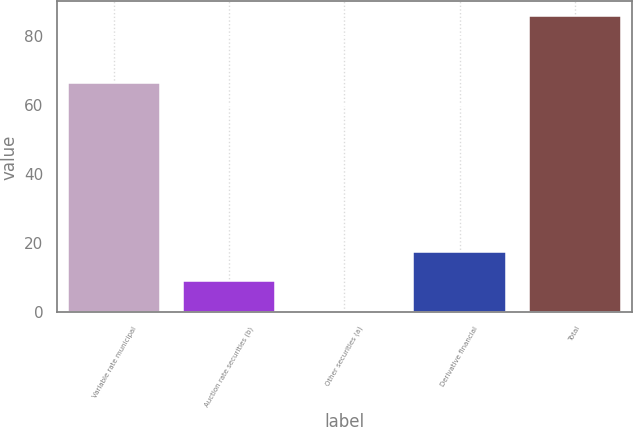Convert chart to OTSL. <chart><loc_0><loc_0><loc_500><loc_500><bar_chart><fcel>Variable rate municipal<fcel>Auction rate securities (b)<fcel>Other securities (a)<fcel>Derivative financial<fcel>Total<nl><fcel>66.5<fcel>8.94<fcel>0.4<fcel>17.48<fcel>85.8<nl></chart> 